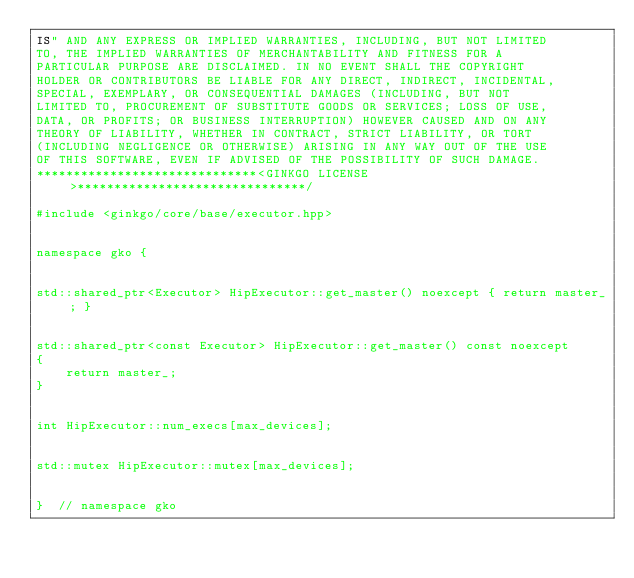<code> <loc_0><loc_0><loc_500><loc_500><_C++_>IS" AND ANY EXPRESS OR IMPLIED WARRANTIES, INCLUDING, BUT NOT LIMITED
TO, THE IMPLIED WARRANTIES OF MERCHANTABILITY AND FITNESS FOR A
PARTICULAR PURPOSE ARE DISCLAIMED. IN NO EVENT SHALL THE COPYRIGHT
HOLDER OR CONTRIBUTORS BE LIABLE FOR ANY DIRECT, INDIRECT, INCIDENTAL,
SPECIAL, EXEMPLARY, OR CONSEQUENTIAL DAMAGES (INCLUDING, BUT NOT
LIMITED TO, PROCUREMENT OF SUBSTITUTE GOODS OR SERVICES; LOSS OF USE,
DATA, OR PROFITS; OR BUSINESS INTERRUPTION) HOWEVER CAUSED AND ON ANY
THEORY OF LIABILITY, WHETHER IN CONTRACT, STRICT LIABILITY, OR TORT
(INCLUDING NEGLIGENCE OR OTHERWISE) ARISING IN ANY WAY OUT OF THE USE
OF THIS SOFTWARE, EVEN IF ADVISED OF THE POSSIBILITY OF SUCH DAMAGE.
******************************<GINKGO LICENSE>*******************************/

#include <ginkgo/core/base/executor.hpp>


namespace gko {


std::shared_ptr<Executor> HipExecutor::get_master() noexcept { return master_; }


std::shared_ptr<const Executor> HipExecutor::get_master() const noexcept
{
    return master_;
}


int HipExecutor::num_execs[max_devices];


std::mutex HipExecutor::mutex[max_devices];


}  // namespace gko
</code> 